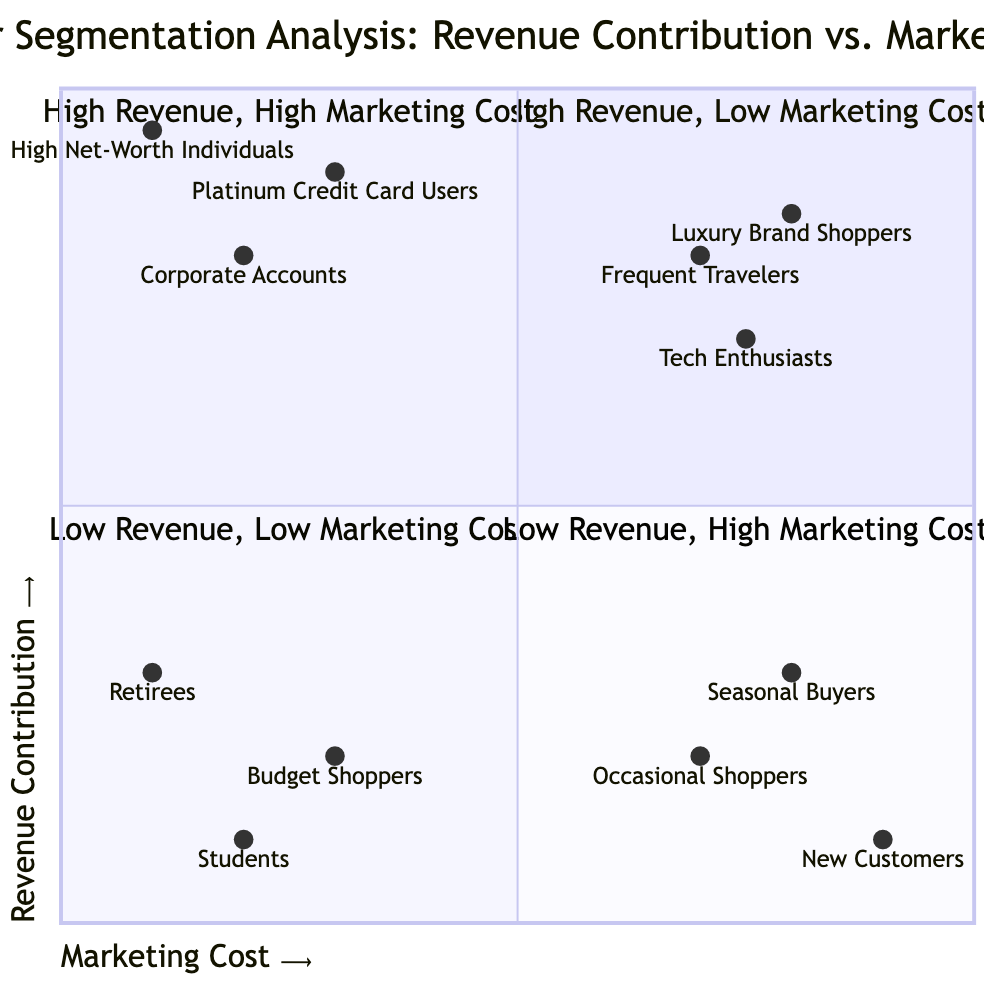What are the segments in the High Revenue, Low Marketing Cost quadrant? The High Revenue, Low Marketing Cost quadrant contains three segments: Corporate Accounts, Platinum Credit Card Users, and High Net-Worth Individuals.
Answer: Corporate Accounts, Platinum Credit Card Users, High Net-Worth Individuals How many segments are there in the Low Revenue, High Marketing Cost quadrant? There is a total of three segments in the Low Revenue, High Marketing Cost quadrant: New Customers, Occasional Shoppers, and Seasonal Buyers.
Answer: 3 Which segment has the highest revenue contribution in the High Revenue, High Marketing Cost quadrant? The segment with the highest revenue contribution in the High Revenue, High Marketing Cost quadrant is Frequent Travelers, who contribute significantly relative to their high marketing cost.
Answer: Frequent Travelers What is the overall trend seen in the quadrants related to marketing costs? The trend shows that as marketing cost increases, revenue contribution does not necessarily increase, as evidenced by segments in both high and low revenue quadrants being spread across high and low marketing costs.
Answer: Increasing costs do not guarantee increased revenue What is the total number of segments represented across all quadrants? There are a total of ten segments represented across all four quadrants: three in High Revenue, Low Marketing Cost, three in High Revenue, High Marketing Cost, three in Low Revenue, Low Marketing Cost, and one in Low Revenue, High Marketing Cost. Therefore, 3 + 3 + 3 + 1 equals 10.
Answer: 10 Which quadrant contains Budget Shoppers? Budget Shoppers are located in the Low Revenue, Low Marketing Cost quadrant, which indicates that they contribute minimally to revenue and incur low marketing expenses.
Answer: Low Revenue, Low Marketing Cost What is the marketing cost for High Net-Worth Individuals? The marketing cost for High Net-Worth Individuals is indicated as 0.1 on the x-axis, placing them in the High Revenue, Low Marketing Cost quadrant.
Answer: 0.1 According to the diagram, what can be inferred about Seasonal Buyers in terms of revenue and marketing? Seasonal Buyers are categorized in the Low Revenue, High Marketing Cost quadrant, indicating that they generate low revenue while incurring relatively high marketing costs. This suggests they may need reevaluation in terms of marketing strategy.
Answer: Low revenue, high marketing cost 